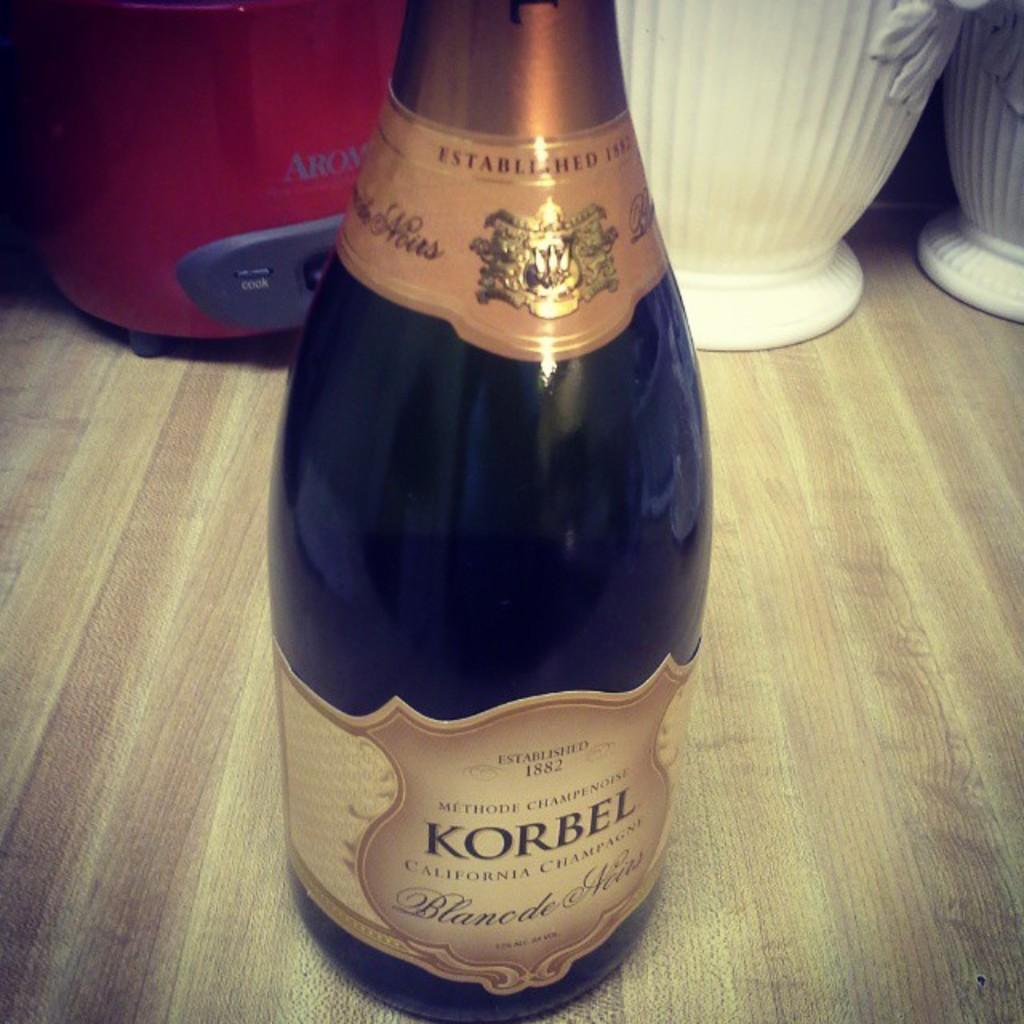<image>
Relay a brief, clear account of the picture shown. A bottle of Korbel is sitting on a wood surface 